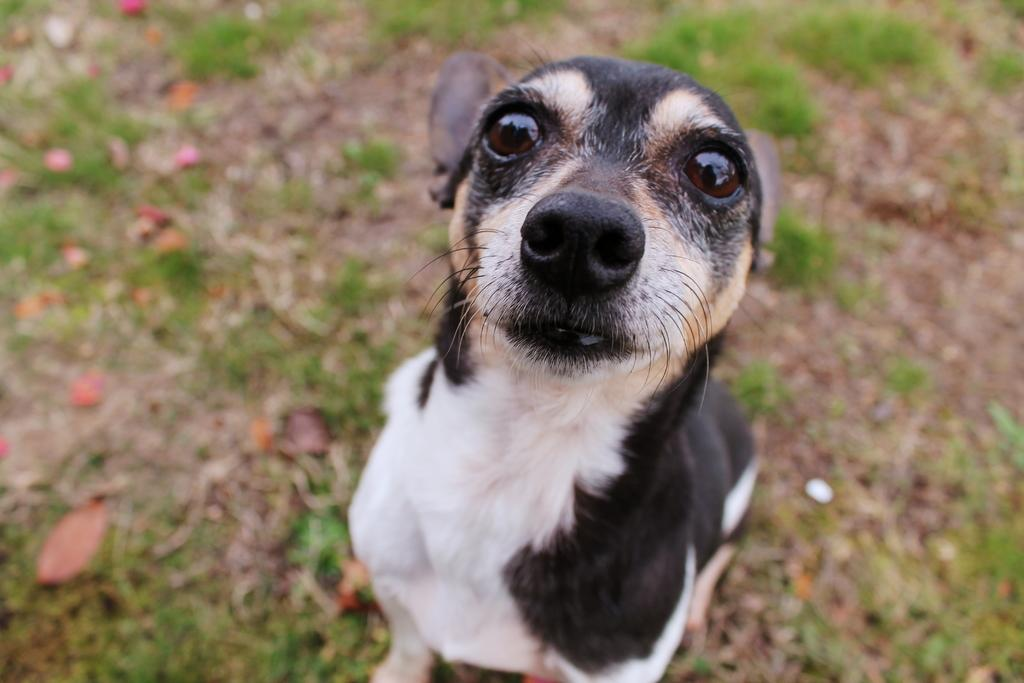What animal is present in the image? There is a dog in the image. What is the dog doing in the image? The dog is standing on the ground. Can you describe the background of the image? The background of the image is slightly blurred, and grass and dry leaves are visible. Can you tell me how many times the dog swims in the image? There is no swimming activity depicted in the image; the dog is standing on the ground. What type of action is the dog performing in the image? The dog is standing on the ground, which is not an action typically described as "action." 